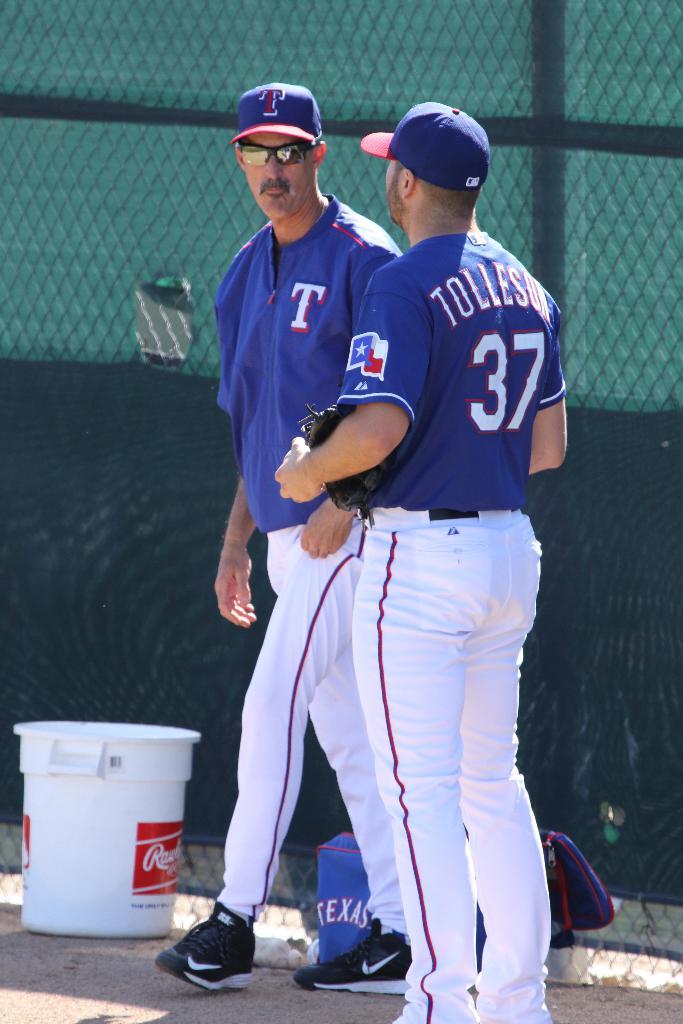What player number is facing away from the camera?
Provide a succinct answer. 37. Which state does this team represent?
Make the answer very short. Texas. 